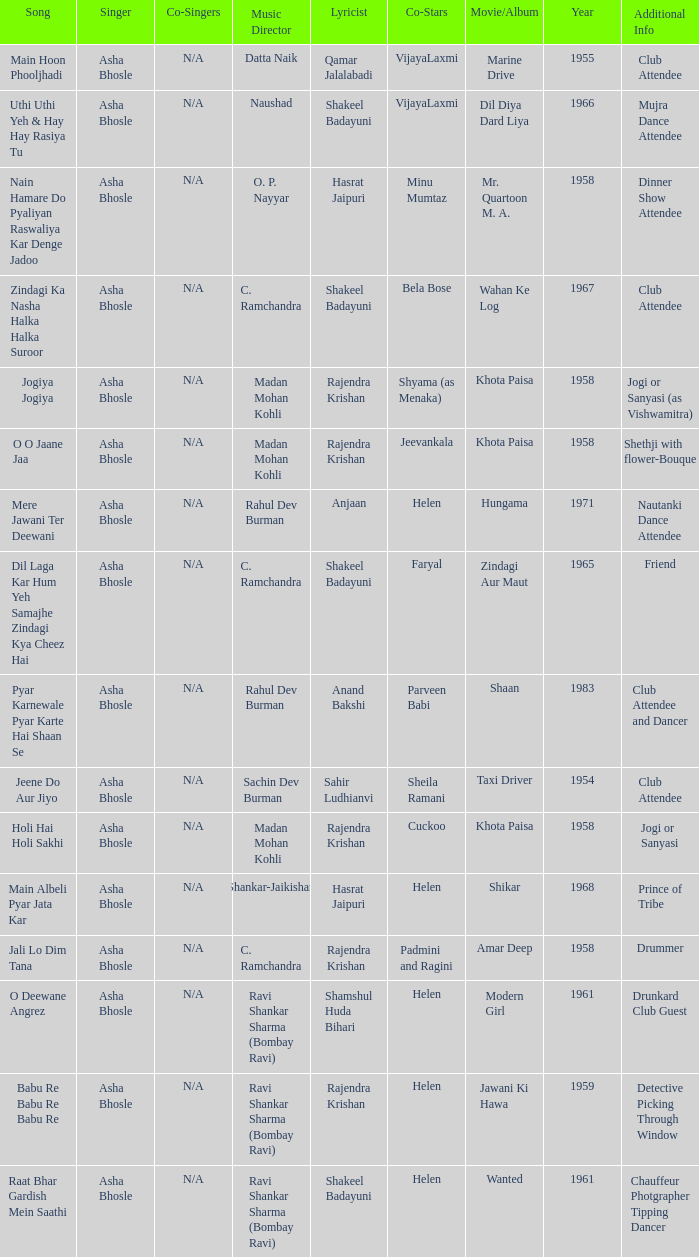What movie did Vijayalaxmi Co-star in and Shakeel Badayuni write the lyrics? Dil Diya Dard Liya. 